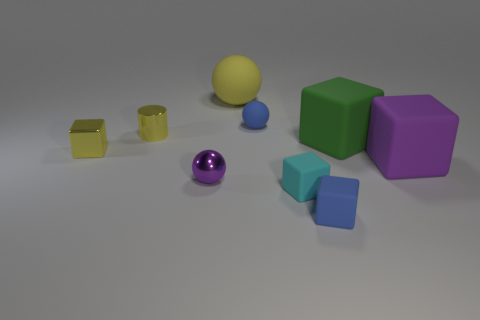Subtract all blue spheres. Subtract all red blocks. How many spheres are left? 2 Add 1 tiny cyan objects. How many objects exist? 10 Subtract all balls. How many objects are left? 6 Add 3 yellow things. How many yellow things are left? 6 Add 8 cyan metal cylinders. How many cyan metal cylinders exist? 8 Subtract 1 yellow cylinders. How many objects are left? 8 Subtract all gray metal balls. Subtract all metal blocks. How many objects are left? 8 